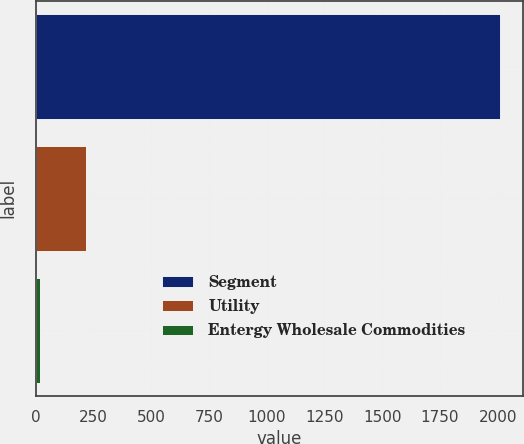Convert chart to OTSL. <chart><loc_0><loc_0><loc_500><loc_500><bar_chart><fcel>Segment<fcel>Utility<fcel>Entergy Wholesale Commodities<nl><fcel>2011<fcel>220<fcel>21<nl></chart> 